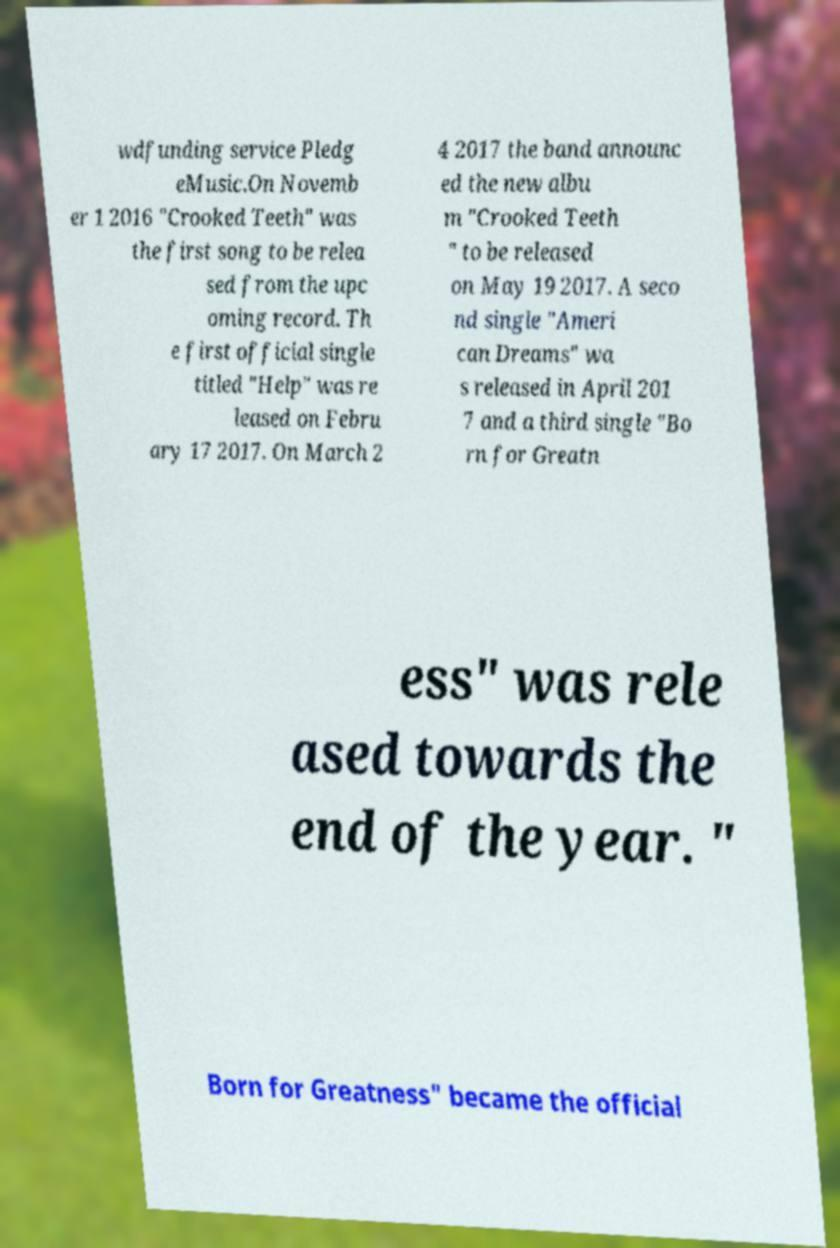Please identify and transcribe the text found in this image. wdfunding service Pledg eMusic.On Novemb er 1 2016 "Crooked Teeth" was the first song to be relea sed from the upc oming record. Th e first official single titled "Help" was re leased on Febru ary 17 2017. On March 2 4 2017 the band announc ed the new albu m "Crooked Teeth " to be released on May 19 2017. A seco nd single "Ameri can Dreams" wa s released in April 201 7 and a third single "Bo rn for Greatn ess" was rele ased towards the end of the year. " Born for Greatness" became the official 